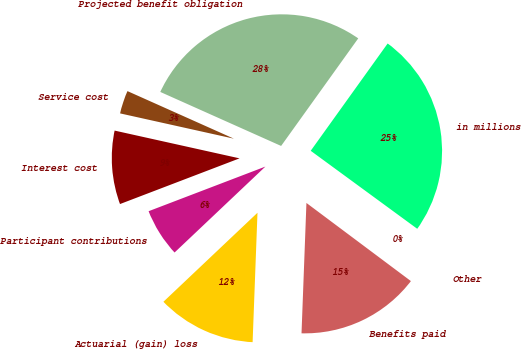Convert chart to OTSL. <chart><loc_0><loc_0><loc_500><loc_500><pie_chart><fcel>in millions<fcel>Projected benefit obligation<fcel>Service cost<fcel>Interest cost<fcel>Participant contributions<fcel>Actuarial (gain) loss<fcel>Benefits paid<fcel>Other<nl><fcel>25.16%<fcel>28.21%<fcel>3.21%<fcel>9.29%<fcel>6.25%<fcel>12.34%<fcel>15.38%<fcel>0.16%<nl></chart> 